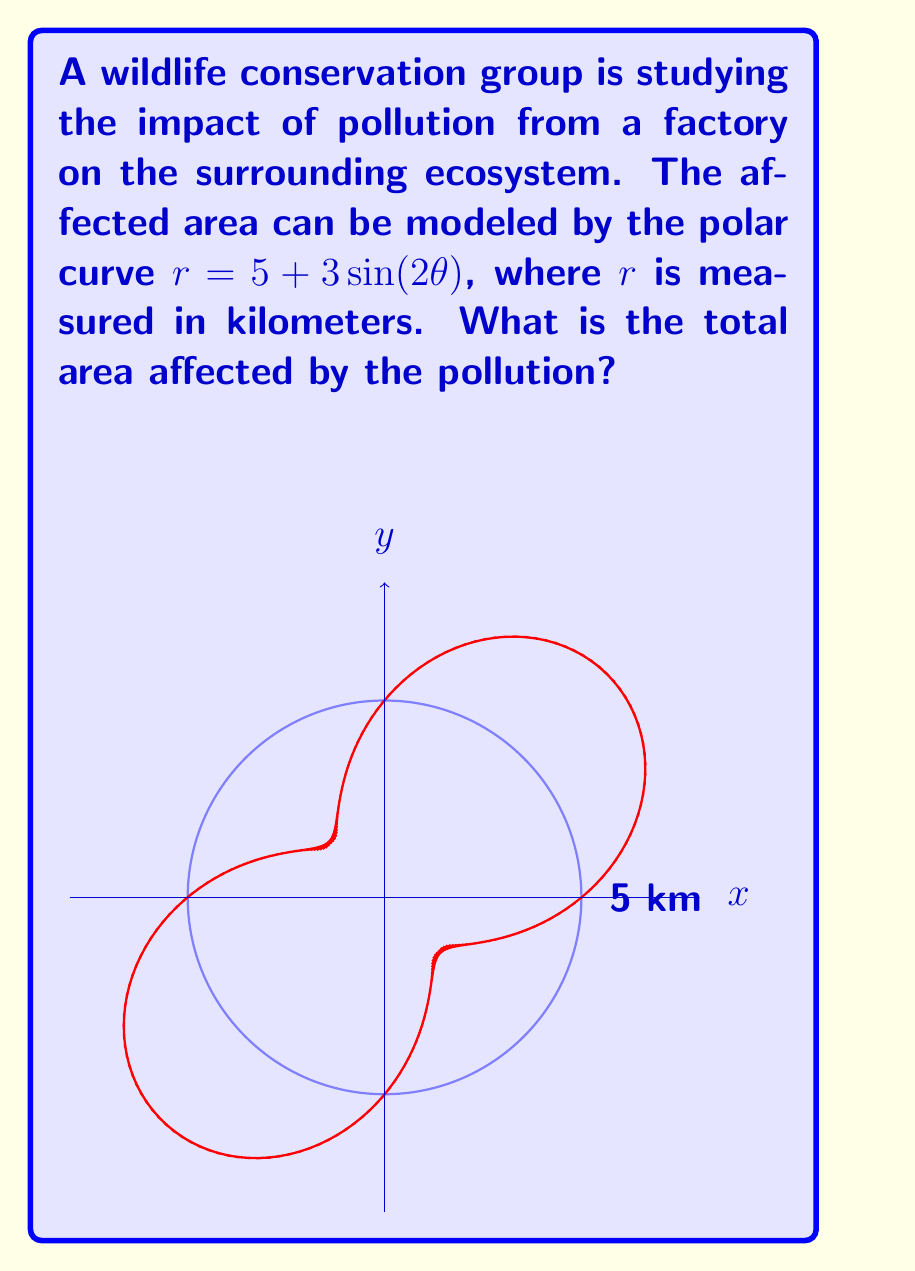Can you answer this question? To solve this problem, we'll follow these steps:

1) The area of a region bounded by a polar curve is given by the formula:

   $$A = \frac{1}{2} \int_{0}^{2\pi} r^2(\theta) d\theta$$

2) In our case, $r(\theta) = 5 + 3\sin(2\theta)$. We need to square this:

   $$r^2(\theta) = (5 + 3\sin(2\theta))^2 = 25 + 30\sin(2\theta) + 9\sin^2(2\theta)$$

3) Now, we can set up our integral:

   $$A = \frac{1}{2} \int_{0}^{2\pi} (25 + 30\sin(2\theta) + 9\sin^2(2\theta)) d\theta$$

4) Let's integrate each term separately:
   
   a) $\int_{0}^{2\pi} 25 d\theta = 25\theta \big|_{0}^{2\pi} = 50\pi$
   
   b) $\int_{0}^{2\pi} 30\sin(2\theta) d\theta = -15\cos(2\theta) \big|_{0}^{2\pi} = 0$
   
   c) For the $\sin^2$ term, we can use the identity $\sin^2x = \frac{1}{2}(1-\cos(2x))$:
      
      $\int_{0}^{2\pi} 9\sin^2(2\theta) d\theta = \int_{0}^{2\pi} \frac{9}{2}(1-\cos(4\theta)) d\theta$
      
      $= \frac{9}{2}\theta - \frac{9}{8}\sin(4\theta) \big|_{0}^{2\pi} = 9\pi$

5) Adding these results:

   $$A = \frac{1}{2}(50\pi + 0 + 9\pi) = \frac{59\pi}{2}$$

6) Therefore, the total area affected is $\frac{59\pi}{2}$ square kilometers.
Answer: $\frac{59\pi}{2}$ sq km 